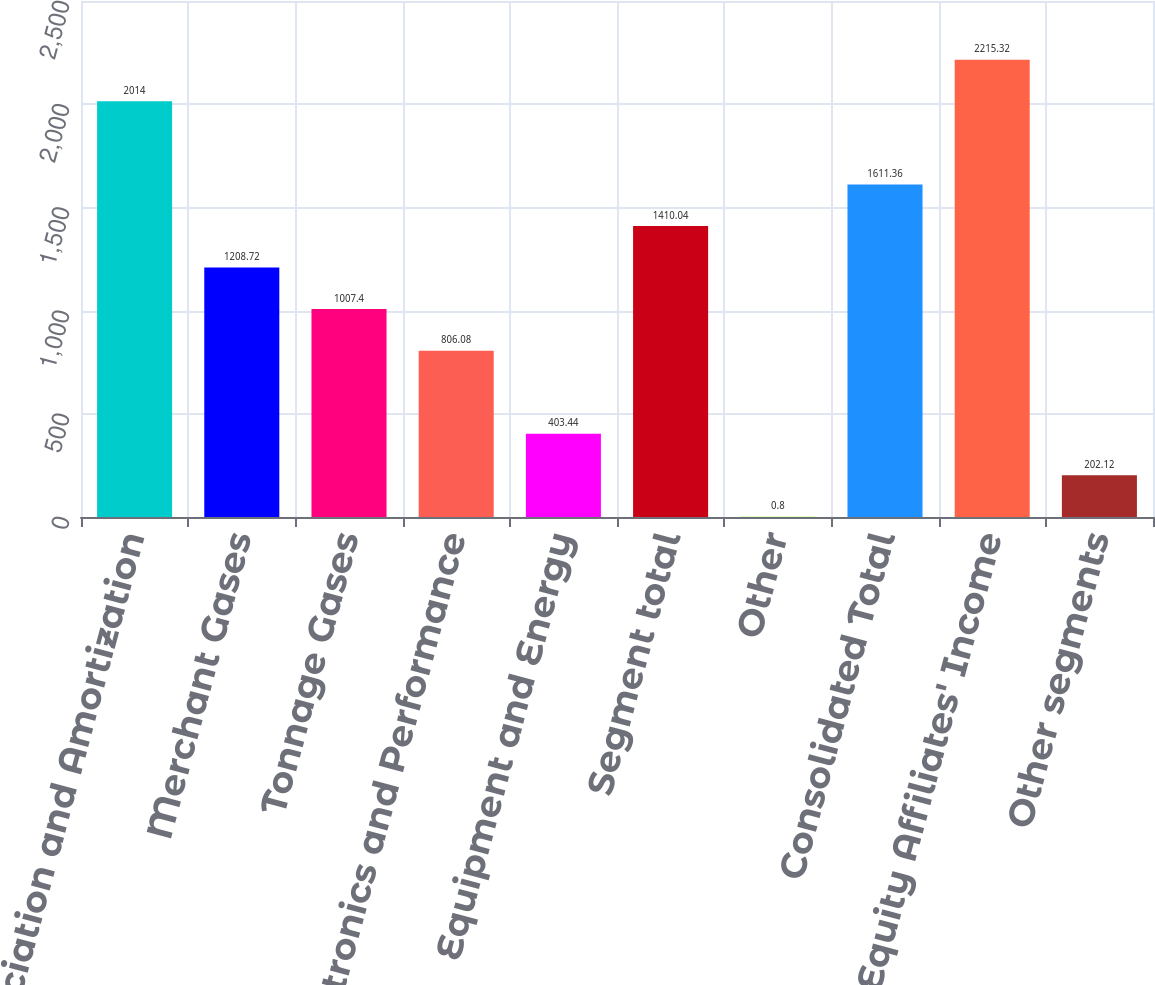<chart> <loc_0><loc_0><loc_500><loc_500><bar_chart><fcel>Depreciation and Amortization<fcel>Merchant Gases<fcel>Tonnage Gases<fcel>Electronics and Performance<fcel>Equipment and Energy<fcel>Segment total<fcel>Other<fcel>Consolidated Total<fcel>Equity Affiliates' Income<fcel>Other segments<nl><fcel>2014<fcel>1208.72<fcel>1007.4<fcel>806.08<fcel>403.44<fcel>1410.04<fcel>0.8<fcel>1611.36<fcel>2215.32<fcel>202.12<nl></chart> 